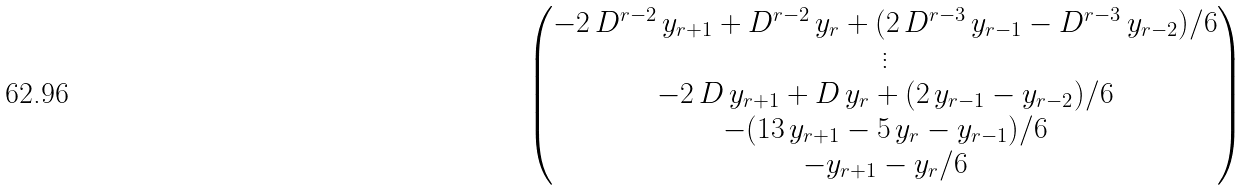Convert formula to latex. <formula><loc_0><loc_0><loc_500><loc_500>\begin{pmatrix} - 2 \, D ^ { r - 2 } \, y _ { r + 1 } + D ^ { r - 2 } \, y _ { r } + ( 2 \, D ^ { r - 3 } \, y _ { r - 1 } - D ^ { r - 3 } \, y _ { r - 2 } ) / 6 \\ \vdots \\ - 2 \, D \, y _ { r + 1 } + D \, y _ { r } + ( 2 \, y _ { r - 1 } - y _ { r - 2 } ) / 6 \\ - ( 1 3 \, y _ { r + 1 } - 5 \, y _ { r } - y _ { r - 1 } ) / 6 \\ - y _ { r + 1 } - y _ { r } / 6 \end{pmatrix}</formula> 